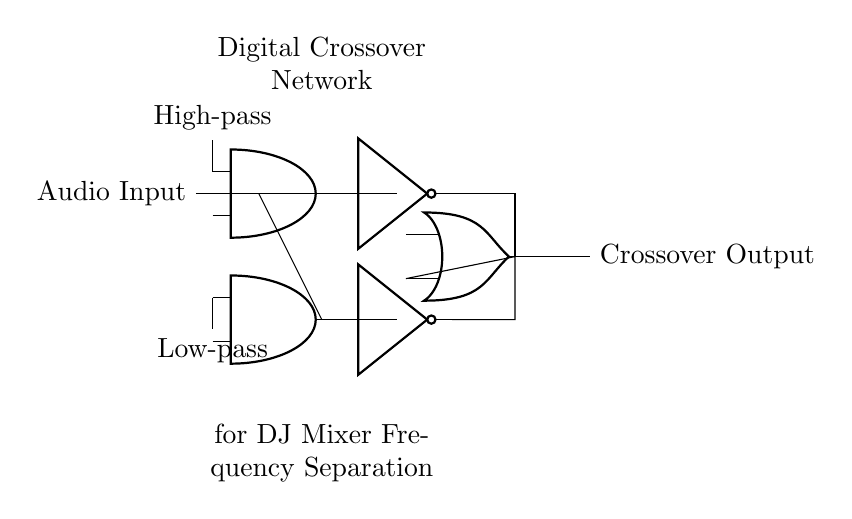What is the main purpose of this circuit? The main purpose of this circuit is to separate audio frequencies for a DJ mixer, allowing for the appropriate output of high and low frequencies.
Answer: Frequency separation What types of filters are used in this circuit? The circuit employs a high-pass filter and a low-pass filter to divide the audio signal. The high-pass filter allows high frequencies to pass while attenuating low frequencies, whereas the low-pass filter does the opposite.
Answer: High-pass and low-pass How many logic gates are present in this circuit? There are three logic gates used in the circuit: two AND gates (for high and low-pass filtering) and one OR gate. This configuration processes the input audio signal into separate frequency bands.
Answer: Three What is the function of the NOT gates in this circuit? The NOT gates invert the output signals from the high-pass and low-pass filters, which can alter the logic levels before they are combined in the OR gate, facilitating the crossover functionality.
Answer: Inversion Which component connects the output of the high-pass filter to the final output? The output of the high-pass filter is connected to a NOT gate, then to an OR gate, which combines it with the output of the low-pass filter before sending it to the crossover output.
Answer: NOT gate Why is an OR gate used after the NOT gates? The OR gate combines the inverted outputs from the NOT gates, allowing both filtered signals to contribute to the final audio output regardless of their frequency characteristics, enabling more versatile audio mixing.
Answer: Combining outputs 